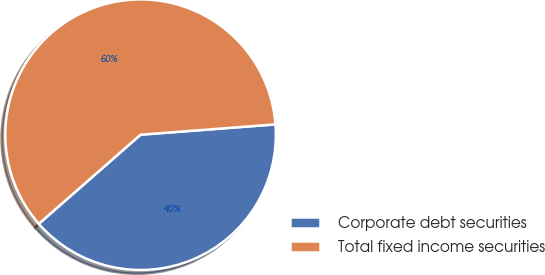Convert chart to OTSL. <chart><loc_0><loc_0><loc_500><loc_500><pie_chart><fcel>Corporate debt securities<fcel>Total fixed income securities<nl><fcel>39.77%<fcel>60.23%<nl></chart> 